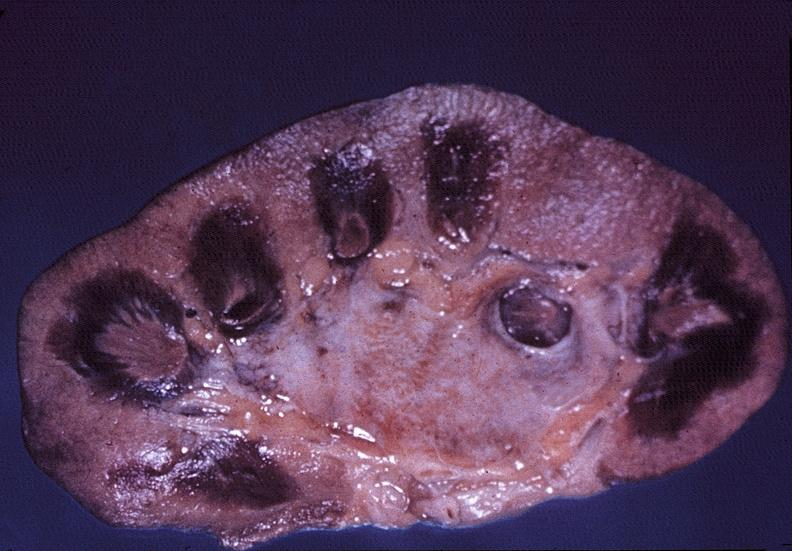does umbilical cord show kidney, papillitis, necrotizing?
Answer the question using a single word or phrase. No 